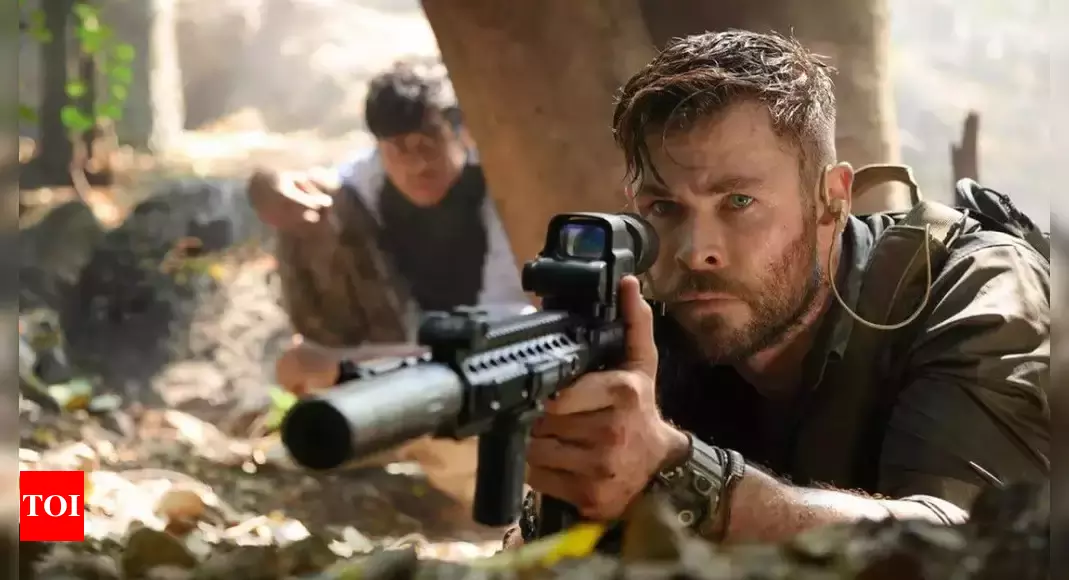What do you see happening in this image? In the image, we see an intense scene from the movie 'Extraction'. The central figure appears to be an actor portraying a determined and focused character, crouching behind a tree and gripping a rifle equipped with a scope. His eyes, filled with concentration, reflect the high-stakes scenario he is in. Behind him, another individual mirrors his position, also crouched and armed, accentuating the gravity of the situation. The backdrop of a dense jungle or forest setting adds elements of mystery and danger, emphasizing the urgency and tension in the scene. 